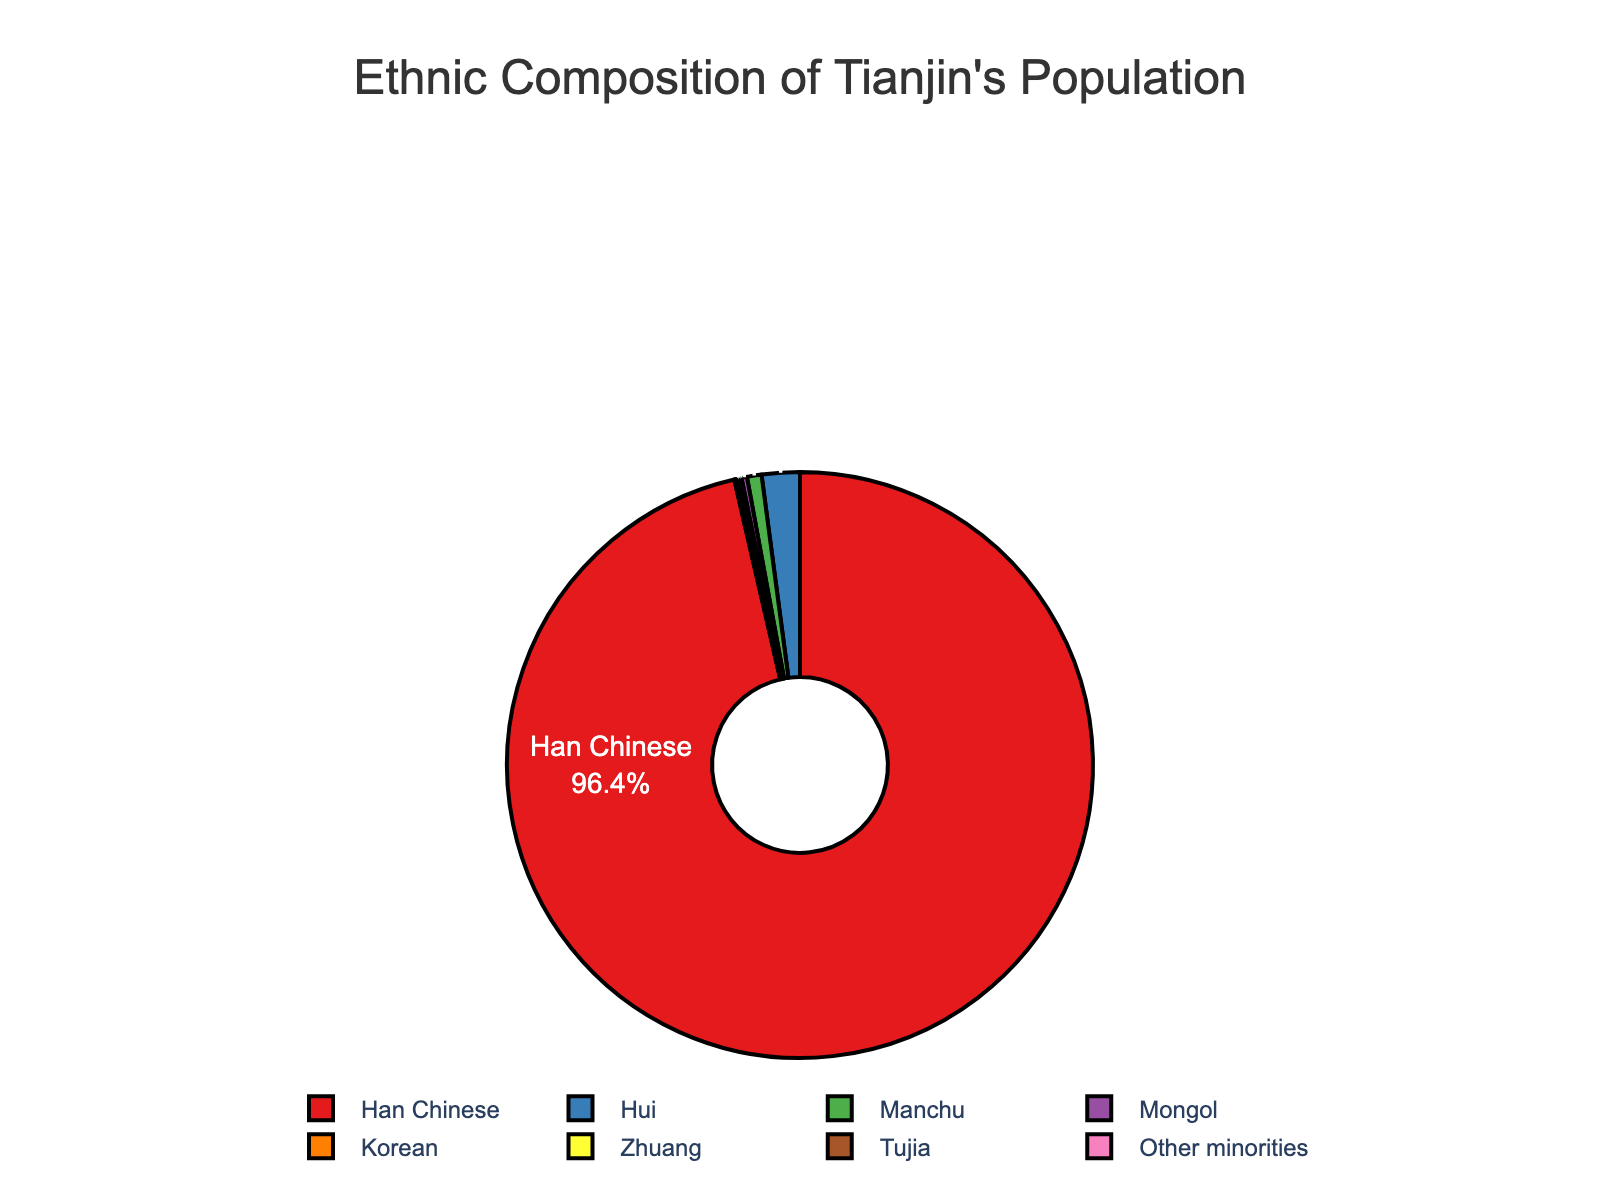What's the largest ethnic group in Tianjin? By observing the figure, the largest portion of the pie chart belongs to the Han Chinese group.
Answer: Han Chinese What is the percentage of Hui population? The pie chart shows the percentage of Hui population near its segment.
Answer: 2.1% How does the percentage of Manchu compare to Mongol? By comparing the sizes and labeled percentages, Manchu is 0.8%, which is greater than Mongol at 0.3%.
Answer: Manchu is greater than Mongol What is the total percentage of minorities other than Han Chinese? Add the percentages of Hui (2.1%), Manchu (0.8%), Mongol (0.3%), Korean (0.1%), Zhuang (0.1%), Tujia (0.1%), and Other minorities (0.1%): 2.1 + 0.8 + 0.3 + 0.1 + 0.1 + 0.1 + 0.1 = 3.6
Answer: 3.6% Which ethnic groups have a population percentage lower than 1%? By identifying segments with percentages lower than 1%, we find Manchu (0.8%), Mongol (0.3%), Korean (0.1%), Zhuang (0.1%), Tujia (0.1%), and Other minorities (0.1%).
Answer: Manchu, Mongol, Korean, Zhuang, Tujia, Other minorities What is the color used for the Han Chinese segment? The Han Chinese segment is depicted using the first color in the defined color scheme, which is red.
Answer: Red If the percentages of Korean, Zhuang, Tujia, and Other minorities were combined, what would their total percentage be? Add the percentages of Korean (0.1%), Zhuang (0.1%), Tujia (0.1%), and Other minorities (0.1%): 0.1 + 0.1 + 0.1 + 0.1 = 0.4
Answer: 0.4% How much larger is the Han Chinese percentage compared to the Hui percentage? Subtract the Hui percentage (2.1%) from the Han Chinese percentage (96.4%): 96.4 - 2.1 = 94.3
Answer: 94.3 Which ethnic group is closest in percentage to the Hui population? By comparing the segments, the Manchu population (0.8%) is the closest to the Hui population (2.1%).
Answer: Manchu What proportion of Tianjin's population is represented by the combined percentage of the Manchu and Mongol groups? Add the percentages of Manchu (0.8%) and Mongol (0.3%): 0.8 + 0.3 = 1.1
Answer: 1.1 